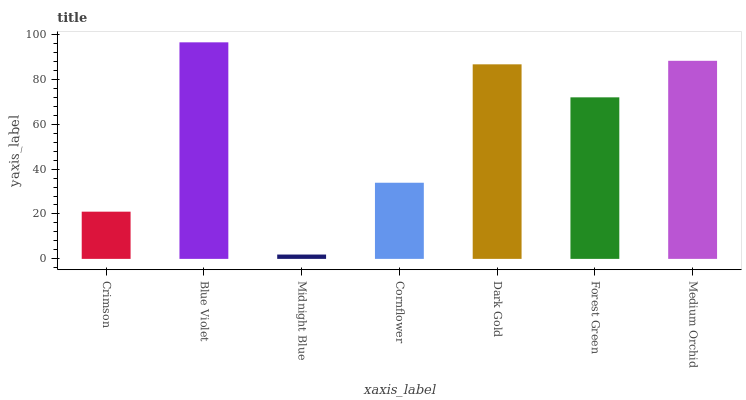Is Blue Violet the minimum?
Answer yes or no. No. Is Midnight Blue the maximum?
Answer yes or no. No. Is Blue Violet greater than Midnight Blue?
Answer yes or no. Yes. Is Midnight Blue less than Blue Violet?
Answer yes or no. Yes. Is Midnight Blue greater than Blue Violet?
Answer yes or no. No. Is Blue Violet less than Midnight Blue?
Answer yes or no. No. Is Forest Green the high median?
Answer yes or no. Yes. Is Forest Green the low median?
Answer yes or no. Yes. Is Dark Gold the high median?
Answer yes or no. No. Is Crimson the low median?
Answer yes or no. No. 